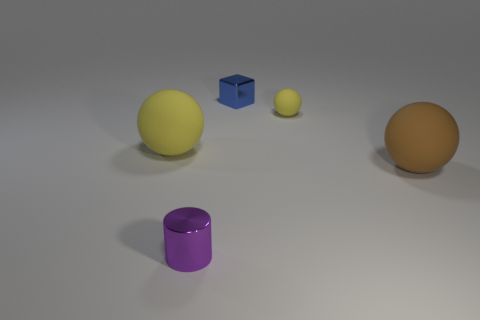Subtract all tiny balls. How many balls are left? 2 Subtract all yellow cylinders. How many yellow balls are left? 2 Subtract all brown spheres. How many spheres are left? 2 Add 5 large purple matte cylinders. How many objects exist? 10 Subtract 2 balls. How many balls are left? 1 Subtract all balls. How many objects are left? 2 Subtract 0 blue cylinders. How many objects are left? 5 Subtract all cyan cylinders. Subtract all blue cubes. How many cylinders are left? 1 Subtract all blue cubes. Subtract all blocks. How many objects are left? 3 Add 5 big yellow matte things. How many big yellow matte things are left? 6 